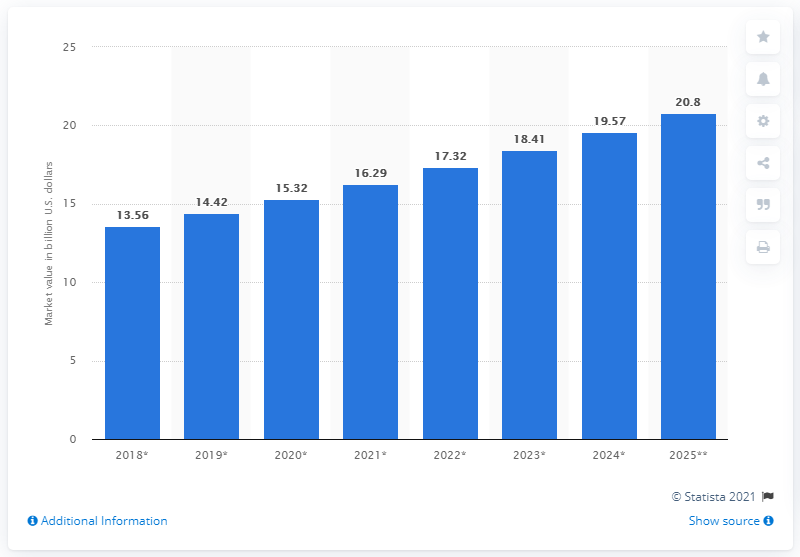Identify some key points in this picture. The global vegan cosmetics market is expected to reach a projected value of 20.8 by 2025. 